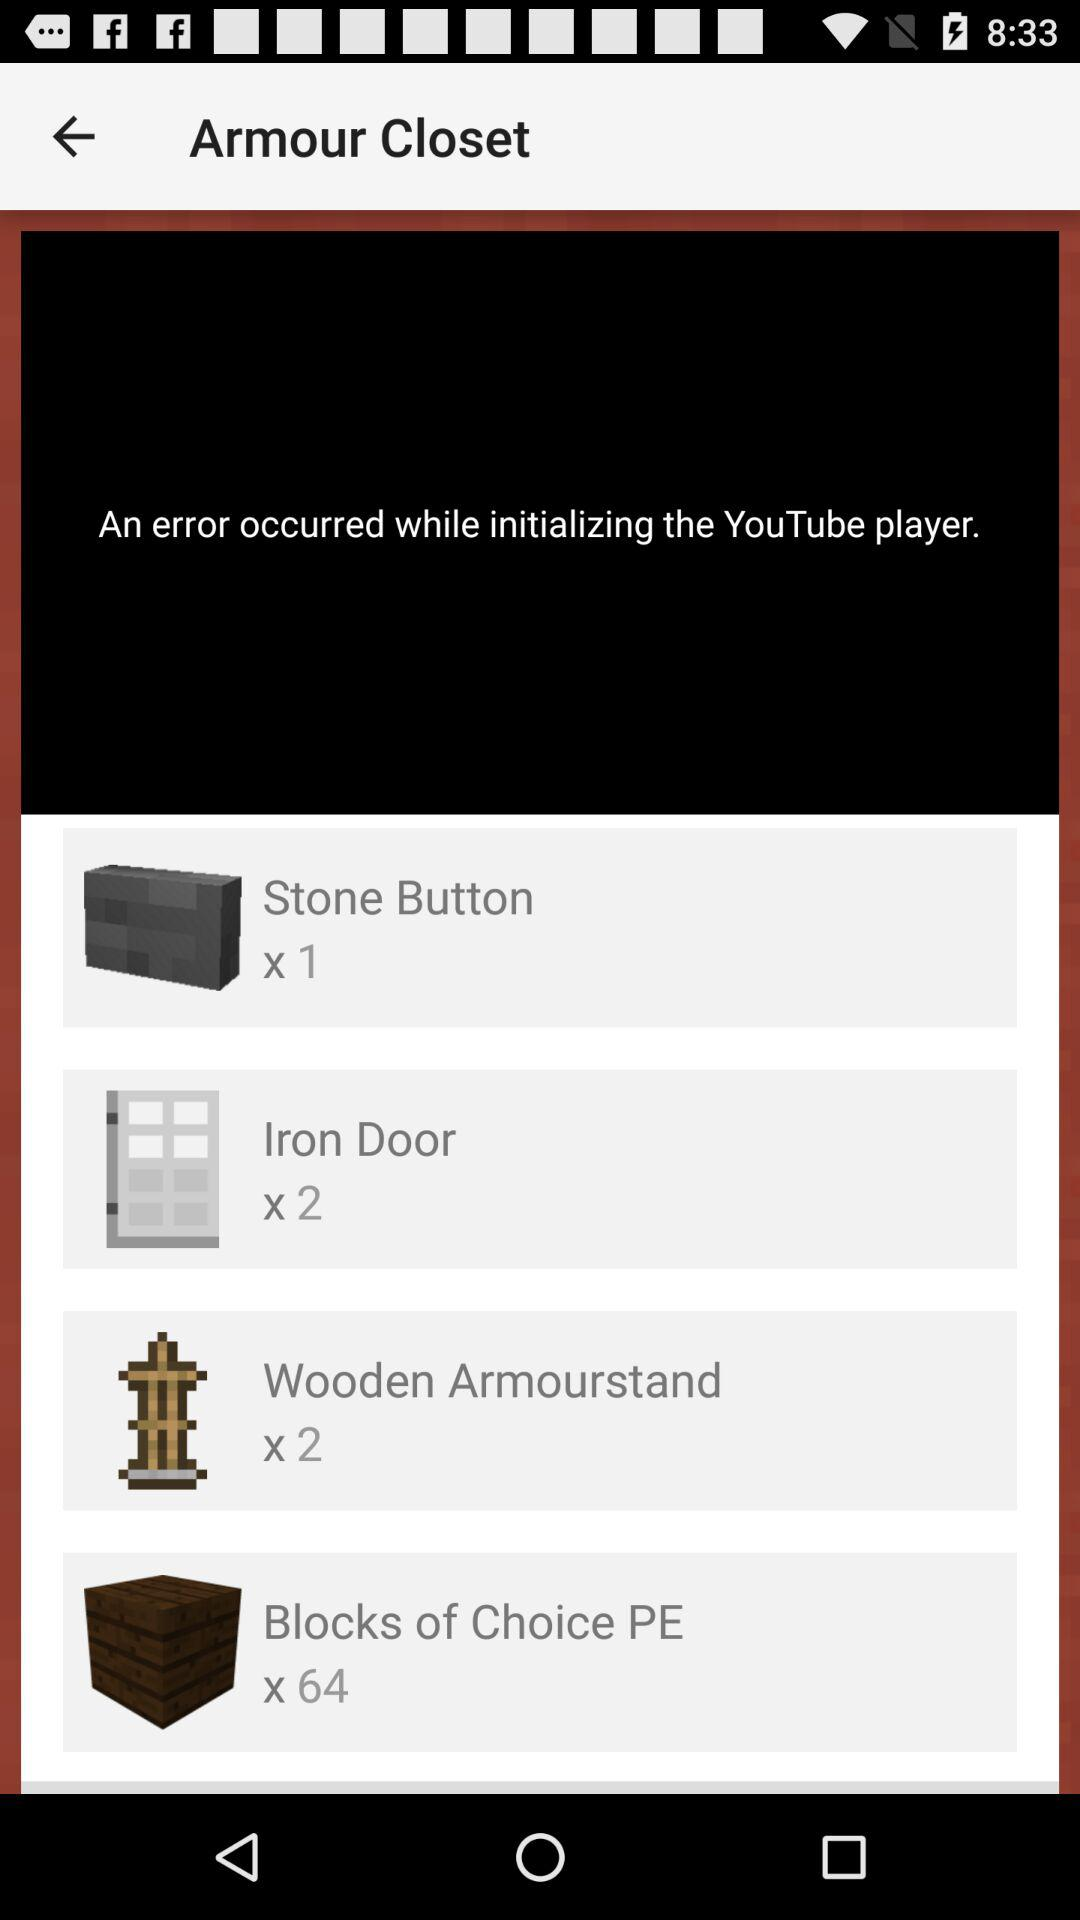How many "Blocks of Choice PE" are there? There are 64 "Blocks of Choice PE". 